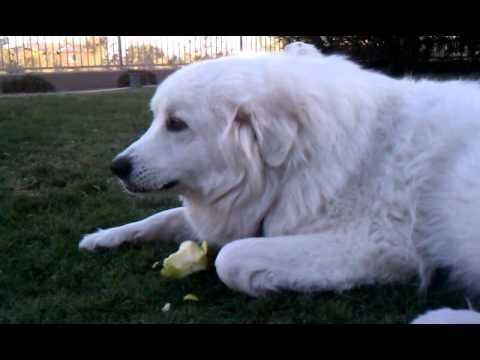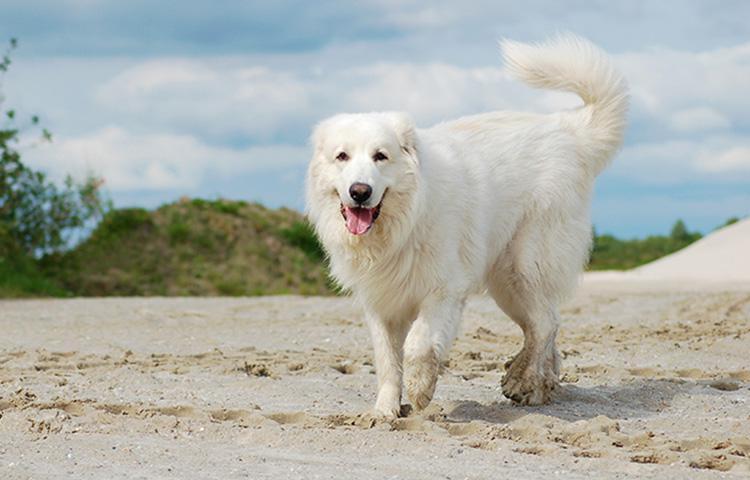The first image is the image on the left, the second image is the image on the right. Assess this claim about the two images: "The dog in the right image has food in its mouth.". Correct or not? Answer yes or no. No. The first image is the image on the left, the second image is the image on the right. Examine the images to the left and right. Is the description "An image shows more than one animal with its face in a round bowl, and at least one of the animals is a white dog." accurate? Answer yes or no. No. 